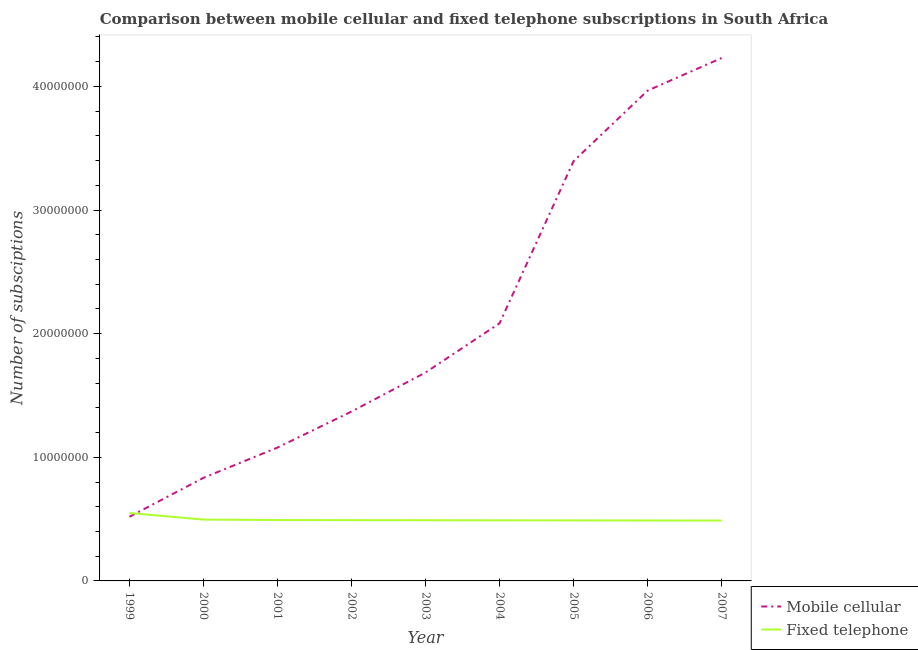How many different coloured lines are there?
Offer a terse response. 2. Is the number of lines equal to the number of legend labels?
Offer a terse response. Yes. What is the number of fixed telephone subscriptions in 2005?
Provide a succinct answer. 4.90e+06. Across all years, what is the maximum number of mobile cellular subscriptions?
Your answer should be very brief. 4.23e+07. Across all years, what is the minimum number of fixed telephone subscriptions?
Your answer should be compact. 4.88e+06. In which year was the number of mobile cellular subscriptions maximum?
Ensure brevity in your answer.  2007. What is the total number of fixed telephone subscriptions in the graph?
Offer a terse response. 4.48e+07. What is the difference between the number of fixed telephone subscriptions in 2005 and that in 2006?
Your response must be concise. 7000. What is the difference between the number of fixed telephone subscriptions in 2002 and the number of mobile cellular subscriptions in 2005?
Give a very brief answer. -2.90e+07. What is the average number of mobile cellular subscriptions per year?
Provide a short and direct response. 2.13e+07. In the year 2007, what is the difference between the number of mobile cellular subscriptions and number of fixed telephone subscriptions?
Offer a terse response. 3.74e+07. In how many years, is the number of fixed telephone subscriptions greater than 28000000?
Provide a short and direct response. 0. What is the ratio of the number of mobile cellular subscriptions in 2004 to that in 2007?
Offer a terse response. 0.49. Is the number of mobile cellular subscriptions in 2002 less than that in 2004?
Your response must be concise. Yes. Is the difference between the number of mobile cellular subscriptions in 2003 and 2007 greater than the difference between the number of fixed telephone subscriptions in 2003 and 2007?
Provide a succinct answer. No. What is the difference between the highest and the second highest number of fixed telephone subscriptions?
Provide a short and direct response. 5.31e+05. What is the difference between the highest and the lowest number of fixed telephone subscriptions?
Your response must be concise. 6.11e+05. In how many years, is the number of mobile cellular subscriptions greater than the average number of mobile cellular subscriptions taken over all years?
Make the answer very short. 3. Does the number of fixed telephone subscriptions monotonically increase over the years?
Provide a short and direct response. No. Is the number of mobile cellular subscriptions strictly greater than the number of fixed telephone subscriptions over the years?
Your answer should be very brief. No. Is the number of mobile cellular subscriptions strictly less than the number of fixed telephone subscriptions over the years?
Ensure brevity in your answer.  No. How many lines are there?
Provide a succinct answer. 2. What is the difference between two consecutive major ticks on the Y-axis?
Make the answer very short. 1.00e+07. Where does the legend appear in the graph?
Your answer should be very brief. Bottom right. How are the legend labels stacked?
Make the answer very short. Vertical. What is the title of the graph?
Your answer should be compact. Comparison between mobile cellular and fixed telephone subscriptions in South Africa. What is the label or title of the Y-axis?
Ensure brevity in your answer.  Number of subsciptions. What is the Number of subsciptions in Mobile cellular in 1999?
Provide a succinct answer. 5.19e+06. What is the Number of subsciptions in Fixed telephone in 1999?
Your response must be concise. 5.49e+06. What is the Number of subsciptions in Mobile cellular in 2000?
Your response must be concise. 8.34e+06. What is the Number of subsciptions of Fixed telephone in 2000?
Offer a very short reply. 4.96e+06. What is the Number of subsciptions of Mobile cellular in 2001?
Keep it short and to the point. 1.08e+07. What is the Number of subsciptions of Fixed telephone in 2001?
Keep it short and to the point. 4.92e+06. What is the Number of subsciptions of Mobile cellular in 2002?
Keep it short and to the point. 1.37e+07. What is the Number of subsciptions of Fixed telephone in 2002?
Make the answer very short. 4.92e+06. What is the Number of subsciptions in Mobile cellular in 2003?
Keep it short and to the point. 1.69e+07. What is the Number of subsciptions of Fixed telephone in 2003?
Your answer should be compact. 4.91e+06. What is the Number of subsciptions of Mobile cellular in 2004?
Keep it short and to the point. 2.08e+07. What is the Number of subsciptions in Fixed telephone in 2004?
Your answer should be compact. 4.90e+06. What is the Number of subsciptions in Mobile cellular in 2005?
Offer a terse response. 3.40e+07. What is the Number of subsciptions in Fixed telephone in 2005?
Provide a succinct answer. 4.90e+06. What is the Number of subsciptions in Mobile cellular in 2006?
Make the answer very short. 3.97e+07. What is the Number of subsciptions in Fixed telephone in 2006?
Provide a short and direct response. 4.89e+06. What is the Number of subsciptions in Mobile cellular in 2007?
Ensure brevity in your answer.  4.23e+07. What is the Number of subsciptions of Fixed telephone in 2007?
Provide a short and direct response. 4.88e+06. Across all years, what is the maximum Number of subsciptions in Mobile cellular?
Provide a succinct answer. 4.23e+07. Across all years, what is the maximum Number of subsciptions of Fixed telephone?
Ensure brevity in your answer.  5.49e+06. Across all years, what is the minimum Number of subsciptions in Mobile cellular?
Your answer should be compact. 5.19e+06. Across all years, what is the minimum Number of subsciptions in Fixed telephone?
Make the answer very short. 4.88e+06. What is the total Number of subsciptions of Mobile cellular in the graph?
Your response must be concise. 1.92e+08. What is the total Number of subsciptions in Fixed telephone in the graph?
Ensure brevity in your answer.  4.48e+07. What is the difference between the Number of subsciptions in Mobile cellular in 1999 and that in 2000?
Provide a short and direct response. -3.15e+06. What is the difference between the Number of subsciptions in Fixed telephone in 1999 and that in 2000?
Your response must be concise. 5.31e+05. What is the difference between the Number of subsciptions in Mobile cellular in 1999 and that in 2001?
Ensure brevity in your answer.  -5.60e+06. What is the difference between the Number of subsciptions of Fixed telephone in 1999 and that in 2001?
Ensure brevity in your answer.  5.68e+05. What is the difference between the Number of subsciptions in Mobile cellular in 1999 and that in 2002?
Make the answer very short. -8.51e+06. What is the difference between the Number of subsciptions in Fixed telephone in 1999 and that in 2002?
Your response must be concise. 5.76e+05. What is the difference between the Number of subsciptions in Mobile cellular in 1999 and that in 2003?
Give a very brief answer. -1.17e+07. What is the difference between the Number of subsciptions in Fixed telephone in 1999 and that in 2003?
Give a very brief answer. 5.83e+05. What is the difference between the Number of subsciptions in Mobile cellular in 1999 and that in 2004?
Your response must be concise. -1.57e+07. What is the difference between the Number of subsciptions in Fixed telephone in 1999 and that in 2004?
Provide a succinct answer. 5.90e+05. What is the difference between the Number of subsciptions in Mobile cellular in 1999 and that in 2005?
Make the answer very short. -2.88e+07. What is the difference between the Number of subsciptions of Fixed telephone in 1999 and that in 2005?
Give a very brief answer. 5.97e+05. What is the difference between the Number of subsciptions in Mobile cellular in 1999 and that in 2006?
Your response must be concise. -3.45e+07. What is the difference between the Number of subsciptions in Fixed telephone in 1999 and that in 2006?
Provide a short and direct response. 6.04e+05. What is the difference between the Number of subsciptions in Mobile cellular in 1999 and that in 2007?
Your answer should be very brief. -3.71e+07. What is the difference between the Number of subsciptions in Fixed telephone in 1999 and that in 2007?
Provide a short and direct response. 6.11e+05. What is the difference between the Number of subsciptions of Mobile cellular in 2000 and that in 2001?
Give a very brief answer. -2.45e+06. What is the difference between the Number of subsciptions of Fixed telephone in 2000 and that in 2001?
Provide a succinct answer. 3.73e+04. What is the difference between the Number of subsciptions of Mobile cellular in 2000 and that in 2002?
Your answer should be very brief. -5.36e+06. What is the difference between the Number of subsciptions in Fixed telephone in 2000 and that in 2002?
Your answer should be compact. 4.47e+04. What is the difference between the Number of subsciptions in Mobile cellular in 2000 and that in 2003?
Keep it short and to the point. -8.52e+06. What is the difference between the Number of subsciptions in Fixed telephone in 2000 and that in 2003?
Ensure brevity in your answer.  5.17e+04. What is the difference between the Number of subsciptions in Mobile cellular in 2000 and that in 2004?
Provide a short and direct response. -1.25e+07. What is the difference between the Number of subsciptions of Fixed telephone in 2000 and that in 2004?
Offer a terse response. 5.87e+04. What is the difference between the Number of subsciptions of Mobile cellular in 2000 and that in 2005?
Keep it short and to the point. -2.56e+07. What is the difference between the Number of subsciptions of Fixed telephone in 2000 and that in 2005?
Give a very brief answer. 6.57e+04. What is the difference between the Number of subsciptions in Mobile cellular in 2000 and that in 2006?
Your answer should be very brief. -3.13e+07. What is the difference between the Number of subsciptions in Fixed telephone in 2000 and that in 2006?
Provide a short and direct response. 7.27e+04. What is the difference between the Number of subsciptions of Mobile cellular in 2000 and that in 2007?
Provide a succinct answer. -3.40e+07. What is the difference between the Number of subsciptions of Fixed telephone in 2000 and that in 2007?
Your answer should be very brief. 7.97e+04. What is the difference between the Number of subsciptions of Mobile cellular in 2001 and that in 2002?
Make the answer very short. -2.92e+06. What is the difference between the Number of subsciptions in Fixed telephone in 2001 and that in 2002?
Make the answer very short. 7458. What is the difference between the Number of subsciptions of Mobile cellular in 2001 and that in 2003?
Your answer should be very brief. -6.07e+06. What is the difference between the Number of subsciptions in Fixed telephone in 2001 and that in 2003?
Ensure brevity in your answer.  1.45e+04. What is the difference between the Number of subsciptions of Mobile cellular in 2001 and that in 2004?
Give a very brief answer. -1.01e+07. What is the difference between the Number of subsciptions of Fixed telephone in 2001 and that in 2004?
Ensure brevity in your answer.  2.15e+04. What is the difference between the Number of subsciptions of Mobile cellular in 2001 and that in 2005?
Your response must be concise. -2.32e+07. What is the difference between the Number of subsciptions in Fixed telephone in 2001 and that in 2005?
Give a very brief answer. 2.85e+04. What is the difference between the Number of subsciptions in Mobile cellular in 2001 and that in 2006?
Make the answer very short. -2.89e+07. What is the difference between the Number of subsciptions of Fixed telephone in 2001 and that in 2006?
Keep it short and to the point. 3.55e+04. What is the difference between the Number of subsciptions in Mobile cellular in 2001 and that in 2007?
Keep it short and to the point. -3.15e+07. What is the difference between the Number of subsciptions of Fixed telephone in 2001 and that in 2007?
Your response must be concise. 4.25e+04. What is the difference between the Number of subsciptions in Mobile cellular in 2002 and that in 2003?
Your answer should be very brief. -3.16e+06. What is the difference between the Number of subsciptions in Fixed telephone in 2002 and that in 2003?
Your answer should be compact. 7000. What is the difference between the Number of subsciptions in Mobile cellular in 2002 and that in 2004?
Your answer should be compact. -7.14e+06. What is the difference between the Number of subsciptions in Fixed telephone in 2002 and that in 2004?
Keep it short and to the point. 1.40e+04. What is the difference between the Number of subsciptions of Mobile cellular in 2002 and that in 2005?
Offer a very short reply. -2.03e+07. What is the difference between the Number of subsciptions of Fixed telephone in 2002 and that in 2005?
Provide a short and direct response. 2.10e+04. What is the difference between the Number of subsciptions of Mobile cellular in 2002 and that in 2006?
Offer a very short reply. -2.60e+07. What is the difference between the Number of subsciptions of Fixed telephone in 2002 and that in 2006?
Make the answer very short. 2.80e+04. What is the difference between the Number of subsciptions in Mobile cellular in 2002 and that in 2007?
Give a very brief answer. -2.86e+07. What is the difference between the Number of subsciptions of Fixed telephone in 2002 and that in 2007?
Give a very brief answer. 3.50e+04. What is the difference between the Number of subsciptions of Mobile cellular in 2003 and that in 2004?
Make the answer very short. -3.98e+06. What is the difference between the Number of subsciptions of Fixed telephone in 2003 and that in 2004?
Offer a very short reply. 7000. What is the difference between the Number of subsciptions of Mobile cellular in 2003 and that in 2005?
Your answer should be compact. -1.71e+07. What is the difference between the Number of subsciptions in Fixed telephone in 2003 and that in 2005?
Keep it short and to the point. 1.40e+04. What is the difference between the Number of subsciptions in Mobile cellular in 2003 and that in 2006?
Provide a succinct answer. -2.28e+07. What is the difference between the Number of subsciptions in Fixed telephone in 2003 and that in 2006?
Your answer should be compact. 2.10e+04. What is the difference between the Number of subsciptions of Mobile cellular in 2003 and that in 2007?
Give a very brief answer. -2.54e+07. What is the difference between the Number of subsciptions in Fixed telephone in 2003 and that in 2007?
Provide a short and direct response. 2.80e+04. What is the difference between the Number of subsciptions of Mobile cellular in 2004 and that in 2005?
Make the answer very short. -1.31e+07. What is the difference between the Number of subsciptions of Fixed telephone in 2004 and that in 2005?
Your response must be concise. 7000. What is the difference between the Number of subsciptions in Mobile cellular in 2004 and that in 2006?
Provide a short and direct response. -1.88e+07. What is the difference between the Number of subsciptions of Fixed telephone in 2004 and that in 2006?
Provide a short and direct response. 1.40e+04. What is the difference between the Number of subsciptions of Mobile cellular in 2004 and that in 2007?
Your response must be concise. -2.15e+07. What is the difference between the Number of subsciptions in Fixed telephone in 2004 and that in 2007?
Give a very brief answer. 2.10e+04. What is the difference between the Number of subsciptions of Mobile cellular in 2005 and that in 2006?
Your response must be concise. -5.70e+06. What is the difference between the Number of subsciptions in Fixed telephone in 2005 and that in 2006?
Provide a succinct answer. 7000. What is the difference between the Number of subsciptions in Mobile cellular in 2005 and that in 2007?
Give a very brief answer. -8.34e+06. What is the difference between the Number of subsciptions in Fixed telephone in 2005 and that in 2007?
Your response must be concise. 1.40e+04. What is the difference between the Number of subsciptions in Mobile cellular in 2006 and that in 2007?
Offer a very short reply. -2.64e+06. What is the difference between the Number of subsciptions of Fixed telephone in 2006 and that in 2007?
Offer a terse response. 7000. What is the difference between the Number of subsciptions in Mobile cellular in 1999 and the Number of subsciptions in Fixed telephone in 2000?
Give a very brief answer. 2.26e+05. What is the difference between the Number of subsciptions of Mobile cellular in 1999 and the Number of subsciptions of Fixed telephone in 2001?
Keep it short and to the point. 2.64e+05. What is the difference between the Number of subsciptions of Mobile cellular in 1999 and the Number of subsciptions of Fixed telephone in 2002?
Your answer should be very brief. 2.71e+05. What is the difference between the Number of subsciptions in Mobile cellular in 1999 and the Number of subsciptions in Fixed telephone in 2003?
Offer a very short reply. 2.78e+05. What is the difference between the Number of subsciptions in Mobile cellular in 1999 and the Number of subsciptions in Fixed telephone in 2004?
Offer a very short reply. 2.85e+05. What is the difference between the Number of subsciptions in Mobile cellular in 1999 and the Number of subsciptions in Fixed telephone in 2005?
Keep it short and to the point. 2.92e+05. What is the difference between the Number of subsciptions of Mobile cellular in 1999 and the Number of subsciptions of Fixed telephone in 2006?
Keep it short and to the point. 2.99e+05. What is the difference between the Number of subsciptions in Mobile cellular in 1999 and the Number of subsciptions in Fixed telephone in 2007?
Your answer should be very brief. 3.06e+05. What is the difference between the Number of subsciptions in Mobile cellular in 2000 and the Number of subsciptions in Fixed telephone in 2001?
Your answer should be compact. 3.41e+06. What is the difference between the Number of subsciptions of Mobile cellular in 2000 and the Number of subsciptions of Fixed telephone in 2002?
Offer a very short reply. 3.42e+06. What is the difference between the Number of subsciptions in Mobile cellular in 2000 and the Number of subsciptions in Fixed telephone in 2003?
Provide a short and direct response. 3.43e+06. What is the difference between the Number of subsciptions of Mobile cellular in 2000 and the Number of subsciptions of Fixed telephone in 2004?
Provide a succinct answer. 3.44e+06. What is the difference between the Number of subsciptions of Mobile cellular in 2000 and the Number of subsciptions of Fixed telephone in 2005?
Offer a terse response. 3.44e+06. What is the difference between the Number of subsciptions in Mobile cellular in 2000 and the Number of subsciptions in Fixed telephone in 2006?
Ensure brevity in your answer.  3.45e+06. What is the difference between the Number of subsciptions of Mobile cellular in 2000 and the Number of subsciptions of Fixed telephone in 2007?
Your response must be concise. 3.46e+06. What is the difference between the Number of subsciptions in Mobile cellular in 2001 and the Number of subsciptions in Fixed telephone in 2002?
Provide a short and direct response. 5.87e+06. What is the difference between the Number of subsciptions in Mobile cellular in 2001 and the Number of subsciptions in Fixed telephone in 2003?
Keep it short and to the point. 5.88e+06. What is the difference between the Number of subsciptions of Mobile cellular in 2001 and the Number of subsciptions of Fixed telephone in 2004?
Your answer should be very brief. 5.88e+06. What is the difference between the Number of subsciptions of Mobile cellular in 2001 and the Number of subsciptions of Fixed telephone in 2005?
Your answer should be compact. 5.89e+06. What is the difference between the Number of subsciptions of Mobile cellular in 2001 and the Number of subsciptions of Fixed telephone in 2006?
Your answer should be compact. 5.90e+06. What is the difference between the Number of subsciptions of Mobile cellular in 2001 and the Number of subsciptions of Fixed telephone in 2007?
Keep it short and to the point. 5.90e+06. What is the difference between the Number of subsciptions in Mobile cellular in 2002 and the Number of subsciptions in Fixed telephone in 2003?
Keep it short and to the point. 8.79e+06. What is the difference between the Number of subsciptions of Mobile cellular in 2002 and the Number of subsciptions of Fixed telephone in 2004?
Provide a succinct answer. 8.80e+06. What is the difference between the Number of subsciptions in Mobile cellular in 2002 and the Number of subsciptions in Fixed telephone in 2005?
Your answer should be compact. 8.81e+06. What is the difference between the Number of subsciptions in Mobile cellular in 2002 and the Number of subsciptions in Fixed telephone in 2006?
Your response must be concise. 8.81e+06. What is the difference between the Number of subsciptions in Mobile cellular in 2002 and the Number of subsciptions in Fixed telephone in 2007?
Offer a very short reply. 8.82e+06. What is the difference between the Number of subsciptions of Mobile cellular in 2003 and the Number of subsciptions of Fixed telephone in 2004?
Offer a very short reply. 1.20e+07. What is the difference between the Number of subsciptions of Mobile cellular in 2003 and the Number of subsciptions of Fixed telephone in 2005?
Your response must be concise. 1.20e+07. What is the difference between the Number of subsciptions of Mobile cellular in 2003 and the Number of subsciptions of Fixed telephone in 2006?
Provide a succinct answer. 1.20e+07. What is the difference between the Number of subsciptions of Mobile cellular in 2003 and the Number of subsciptions of Fixed telephone in 2007?
Offer a terse response. 1.20e+07. What is the difference between the Number of subsciptions in Mobile cellular in 2004 and the Number of subsciptions in Fixed telephone in 2005?
Your answer should be very brief. 1.59e+07. What is the difference between the Number of subsciptions of Mobile cellular in 2004 and the Number of subsciptions of Fixed telephone in 2006?
Your answer should be very brief. 1.60e+07. What is the difference between the Number of subsciptions in Mobile cellular in 2004 and the Number of subsciptions in Fixed telephone in 2007?
Your answer should be compact. 1.60e+07. What is the difference between the Number of subsciptions in Mobile cellular in 2005 and the Number of subsciptions in Fixed telephone in 2006?
Keep it short and to the point. 2.91e+07. What is the difference between the Number of subsciptions of Mobile cellular in 2005 and the Number of subsciptions of Fixed telephone in 2007?
Keep it short and to the point. 2.91e+07. What is the difference between the Number of subsciptions in Mobile cellular in 2006 and the Number of subsciptions in Fixed telephone in 2007?
Your answer should be compact. 3.48e+07. What is the average Number of subsciptions in Mobile cellular per year?
Offer a terse response. 2.13e+07. What is the average Number of subsciptions of Fixed telephone per year?
Your response must be concise. 4.98e+06. In the year 1999, what is the difference between the Number of subsciptions of Mobile cellular and Number of subsciptions of Fixed telephone?
Provide a short and direct response. -3.05e+05. In the year 2000, what is the difference between the Number of subsciptions in Mobile cellular and Number of subsciptions in Fixed telephone?
Your answer should be very brief. 3.38e+06. In the year 2001, what is the difference between the Number of subsciptions in Mobile cellular and Number of subsciptions in Fixed telephone?
Ensure brevity in your answer.  5.86e+06. In the year 2002, what is the difference between the Number of subsciptions of Mobile cellular and Number of subsciptions of Fixed telephone?
Provide a short and direct response. 8.78e+06. In the year 2003, what is the difference between the Number of subsciptions of Mobile cellular and Number of subsciptions of Fixed telephone?
Ensure brevity in your answer.  1.20e+07. In the year 2004, what is the difference between the Number of subsciptions of Mobile cellular and Number of subsciptions of Fixed telephone?
Keep it short and to the point. 1.59e+07. In the year 2005, what is the difference between the Number of subsciptions in Mobile cellular and Number of subsciptions in Fixed telephone?
Offer a very short reply. 2.91e+07. In the year 2006, what is the difference between the Number of subsciptions of Mobile cellular and Number of subsciptions of Fixed telephone?
Give a very brief answer. 3.48e+07. In the year 2007, what is the difference between the Number of subsciptions of Mobile cellular and Number of subsciptions of Fixed telephone?
Your answer should be compact. 3.74e+07. What is the ratio of the Number of subsciptions in Mobile cellular in 1999 to that in 2000?
Give a very brief answer. 0.62. What is the ratio of the Number of subsciptions in Fixed telephone in 1999 to that in 2000?
Provide a succinct answer. 1.11. What is the ratio of the Number of subsciptions of Mobile cellular in 1999 to that in 2001?
Your answer should be very brief. 0.48. What is the ratio of the Number of subsciptions of Fixed telephone in 1999 to that in 2001?
Offer a terse response. 1.12. What is the ratio of the Number of subsciptions of Mobile cellular in 1999 to that in 2002?
Keep it short and to the point. 0.38. What is the ratio of the Number of subsciptions of Fixed telephone in 1999 to that in 2002?
Your response must be concise. 1.12. What is the ratio of the Number of subsciptions of Mobile cellular in 1999 to that in 2003?
Your answer should be very brief. 0.31. What is the ratio of the Number of subsciptions in Fixed telephone in 1999 to that in 2003?
Provide a succinct answer. 1.12. What is the ratio of the Number of subsciptions in Mobile cellular in 1999 to that in 2004?
Offer a terse response. 0.25. What is the ratio of the Number of subsciptions in Fixed telephone in 1999 to that in 2004?
Your response must be concise. 1.12. What is the ratio of the Number of subsciptions in Mobile cellular in 1999 to that in 2005?
Keep it short and to the point. 0.15. What is the ratio of the Number of subsciptions of Fixed telephone in 1999 to that in 2005?
Your answer should be very brief. 1.12. What is the ratio of the Number of subsciptions of Mobile cellular in 1999 to that in 2006?
Give a very brief answer. 0.13. What is the ratio of the Number of subsciptions in Fixed telephone in 1999 to that in 2006?
Your answer should be very brief. 1.12. What is the ratio of the Number of subsciptions in Mobile cellular in 1999 to that in 2007?
Offer a terse response. 0.12. What is the ratio of the Number of subsciptions of Fixed telephone in 1999 to that in 2007?
Give a very brief answer. 1.13. What is the ratio of the Number of subsciptions of Mobile cellular in 2000 to that in 2001?
Your response must be concise. 0.77. What is the ratio of the Number of subsciptions in Fixed telephone in 2000 to that in 2001?
Offer a very short reply. 1.01. What is the ratio of the Number of subsciptions in Mobile cellular in 2000 to that in 2002?
Keep it short and to the point. 0.61. What is the ratio of the Number of subsciptions in Fixed telephone in 2000 to that in 2002?
Make the answer very short. 1.01. What is the ratio of the Number of subsciptions in Mobile cellular in 2000 to that in 2003?
Your answer should be very brief. 0.49. What is the ratio of the Number of subsciptions in Fixed telephone in 2000 to that in 2003?
Ensure brevity in your answer.  1.01. What is the ratio of the Number of subsciptions in Mobile cellular in 2000 to that in 2004?
Keep it short and to the point. 0.4. What is the ratio of the Number of subsciptions in Mobile cellular in 2000 to that in 2005?
Provide a succinct answer. 0.25. What is the ratio of the Number of subsciptions of Fixed telephone in 2000 to that in 2005?
Make the answer very short. 1.01. What is the ratio of the Number of subsciptions of Mobile cellular in 2000 to that in 2006?
Give a very brief answer. 0.21. What is the ratio of the Number of subsciptions in Fixed telephone in 2000 to that in 2006?
Your answer should be very brief. 1.01. What is the ratio of the Number of subsciptions of Mobile cellular in 2000 to that in 2007?
Your answer should be compact. 0.2. What is the ratio of the Number of subsciptions of Fixed telephone in 2000 to that in 2007?
Provide a short and direct response. 1.02. What is the ratio of the Number of subsciptions of Mobile cellular in 2001 to that in 2002?
Provide a succinct answer. 0.79. What is the ratio of the Number of subsciptions of Mobile cellular in 2001 to that in 2003?
Your response must be concise. 0.64. What is the ratio of the Number of subsciptions of Fixed telephone in 2001 to that in 2003?
Give a very brief answer. 1. What is the ratio of the Number of subsciptions of Mobile cellular in 2001 to that in 2004?
Keep it short and to the point. 0.52. What is the ratio of the Number of subsciptions in Fixed telephone in 2001 to that in 2004?
Your response must be concise. 1. What is the ratio of the Number of subsciptions of Mobile cellular in 2001 to that in 2005?
Offer a terse response. 0.32. What is the ratio of the Number of subsciptions in Mobile cellular in 2001 to that in 2006?
Offer a very short reply. 0.27. What is the ratio of the Number of subsciptions in Fixed telephone in 2001 to that in 2006?
Your answer should be compact. 1.01. What is the ratio of the Number of subsciptions of Mobile cellular in 2001 to that in 2007?
Make the answer very short. 0.26. What is the ratio of the Number of subsciptions of Fixed telephone in 2001 to that in 2007?
Give a very brief answer. 1.01. What is the ratio of the Number of subsciptions of Mobile cellular in 2002 to that in 2003?
Offer a terse response. 0.81. What is the ratio of the Number of subsciptions in Fixed telephone in 2002 to that in 2003?
Offer a very short reply. 1. What is the ratio of the Number of subsciptions of Mobile cellular in 2002 to that in 2004?
Your answer should be very brief. 0.66. What is the ratio of the Number of subsciptions of Fixed telephone in 2002 to that in 2004?
Keep it short and to the point. 1. What is the ratio of the Number of subsciptions of Mobile cellular in 2002 to that in 2005?
Your response must be concise. 0.4. What is the ratio of the Number of subsciptions in Fixed telephone in 2002 to that in 2005?
Ensure brevity in your answer.  1. What is the ratio of the Number of subsciptions in Mobile cellular in 2002 to that in 2006?
Provide a short and direct response. 0.35. What is the ratio of the Number of subsciptions of Fixed telephone in 2002 to that in 2006?
Provide a short and direct response. 1.01. What is the ratio of the Number of subsciptions of Mobile cellular in 2002 to that in 2007?
Offer a very short reply. 0.32. What is the ratio of the Number of subsciptions of Mobile cellular in 2003 to that in 2004?
Give a very brief answer. 0.81. What is the ratio of the Number of subsciptions of Mobile cellular in 2003 to that in 2005?
Provide a succinct answer. 0.5. What is the ratio of the Number of subsciptions in Fixed telephone in 2003 to that in 2005?
Keep it short and to the point. 1. What is the ratio of the Number of subsciptions of Mobile cellular in 2003 to that in 2006?
Your answer should be very brief. 0.43. What is the ratio of the Number of subsciptions of Mobile cellular in 2003 to that in 2007?
Ensure brevity in your answer.  0.4. What is the ratio of the Number of subsciptions in Fixed telephone in 2003 to that in 2007?
Keep it short and to the point. 1.01. What is the ratio of the Number of subsciptions of Mobile cellular in 2004 to that in 2005?
Offer a terse response. 0.61. What is the ratio of the Number of subsciptions in Mobile cellular in 2004 to that in 2006?
Make the answer very short. 0.53. What is the ratio of the Number of subsciptions of Mobile cellular in 2004 to that in 2007?
Your answer should be compact. 0.49. What is the ratio of the Number of subsciptions in Mobile cellular in 2005 to that in 2006?
Keep it short and to the point. 0.86. What is the ratio of the Number of subsciptions of Mobile cellular in 2005 to that in 2007?
Give a very brief answer. 0.8. What is the ratio of the Number of subsciptions of Mobile cellular in 2006 to that in 2007?
Your answer should be compact. 0.94. What is the difference between the highest and the second highest Number of subsciptions in Mobile cellular?
Offer a terse response. 2.64e+06. What is the difference between the highest and the second highest Number of subsciptions of Fixed telephone?
Your answer should be very brief. 5.31e+05. What is the difference between the highest and the lowest Number of subsciptions in Mobile cellular?
Provide a short and direct response. 3.71e+07. What is the difference between the highest and the lowest Number of subsciptions of Fixed telephone?
Offer a very short reply. 6.11e+05. 